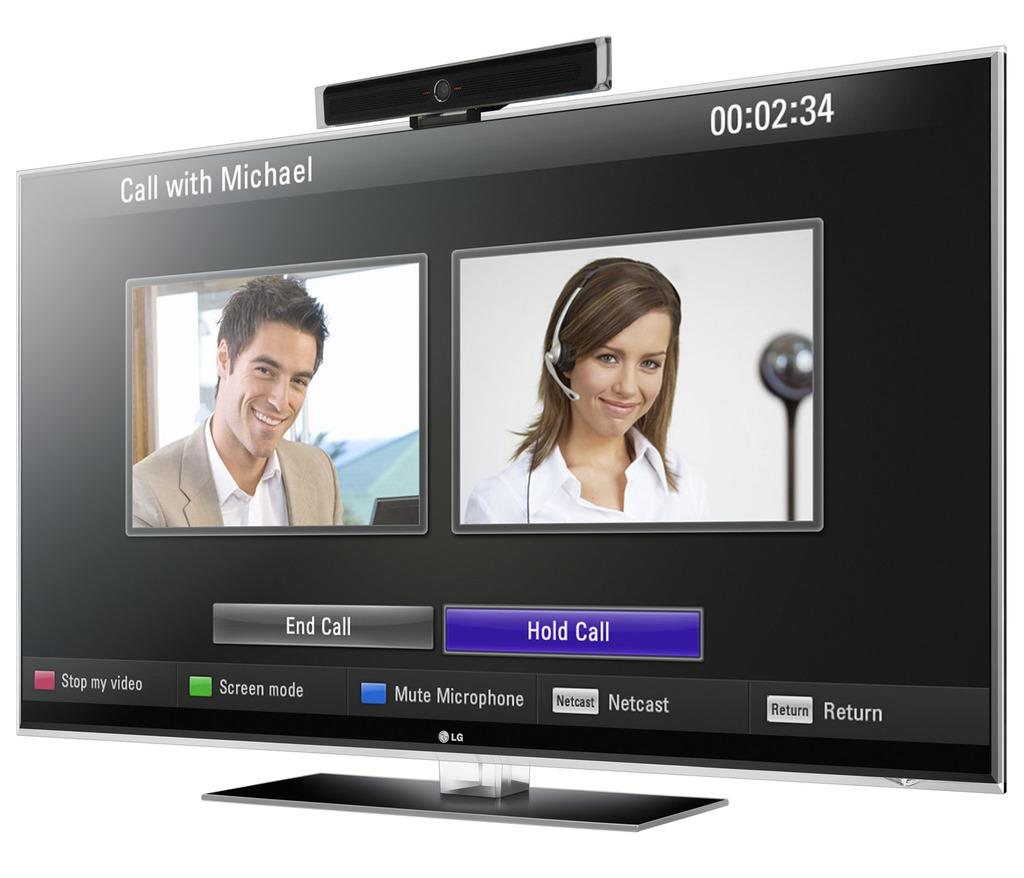<image>
Write a terse but informative summary of the picture. LG computer screen that shows a man on the left and woman on the right 